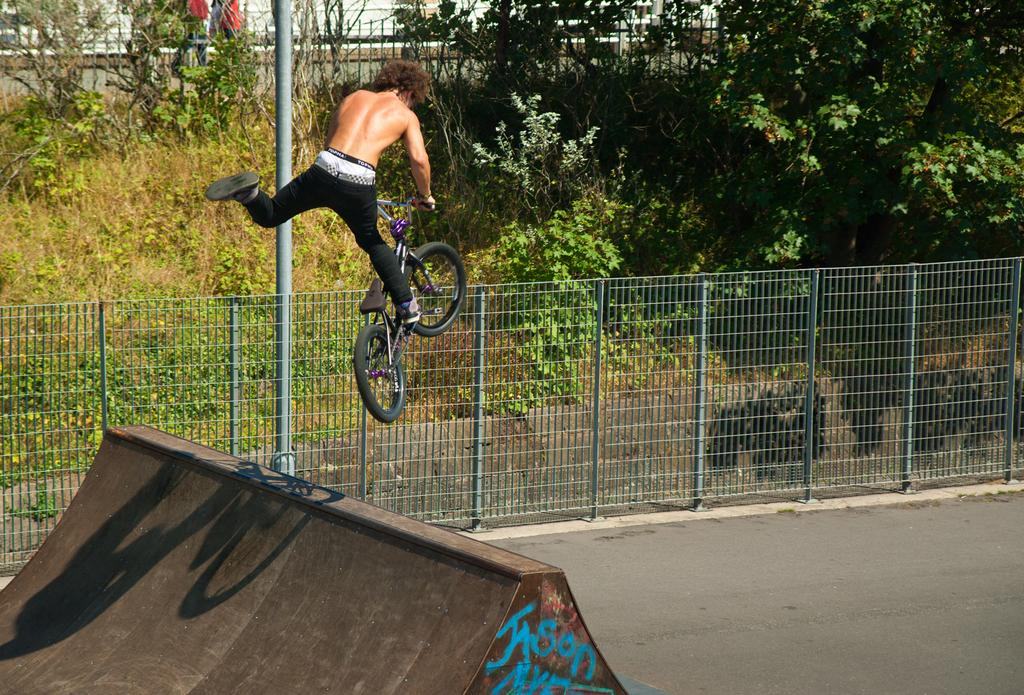What is the main subject of the image? There is a bicycle rider in the image. What is located near the bicycle rider? There is an object near the bicycle rider. What type of barrier can be seen in the image? There is an iron fence in the image. What vertical structure is present in the image? There is a pole in the image. What can be seen in the background of the image? There are trees in the background of the image. Reasoning: Let' Let's think step by step in order to produce the conversation. We start by identifying the main subject of the image, which is the bicycle rider. Then, we describe the object near the rider and the presence of an iron fence and a pole. We also mention the trees in the background to give a sense of the setting. Each question is designed to elicit a specific detail about the image that is known from the provided facts. Absurd Question/Answer: What type of education does the bicycle rider have in the image? There is no information about the bicycle rider's education in the image. What is the position of the bicycle rider in the image? The position of the bicycle rider in the image cannot be determined without more context or information about the scene. 